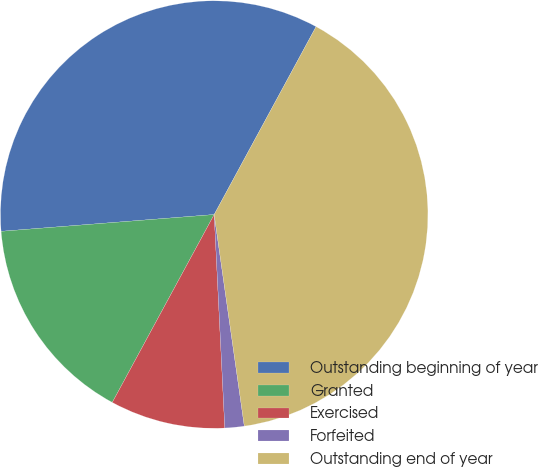Convert chart to OTSL. <chart><loc_0><loc_0><loc_500><loc_500><pie_chart><fcel>Outstanding beginning of year<fcel>Granted<fcel>Exercised<fcel>Forfeited<fcel>Outstanding end of year<nl><fcel>34.16%<fcel>15.84%<fcel>8.7%<fcel>1.46%<fcel>39.84%<nl></chart> 